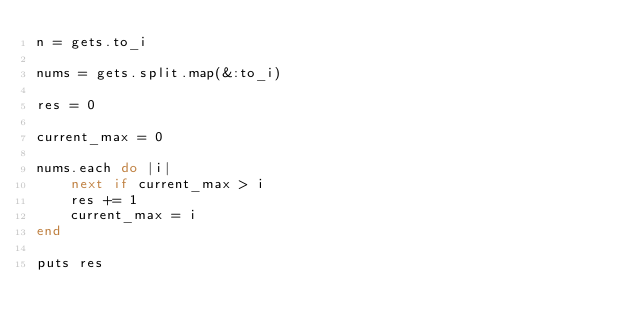<code> <loc_0><loc_0><loc_500><loc_500><_Ruby_>n = gets.to_i

nums = gets.split.map(&:to_i)

res = 0

current_max = 0

nums.each do |i|
    next if current_max > i
    res += 1
    current_max = i
end

puts res</code> 